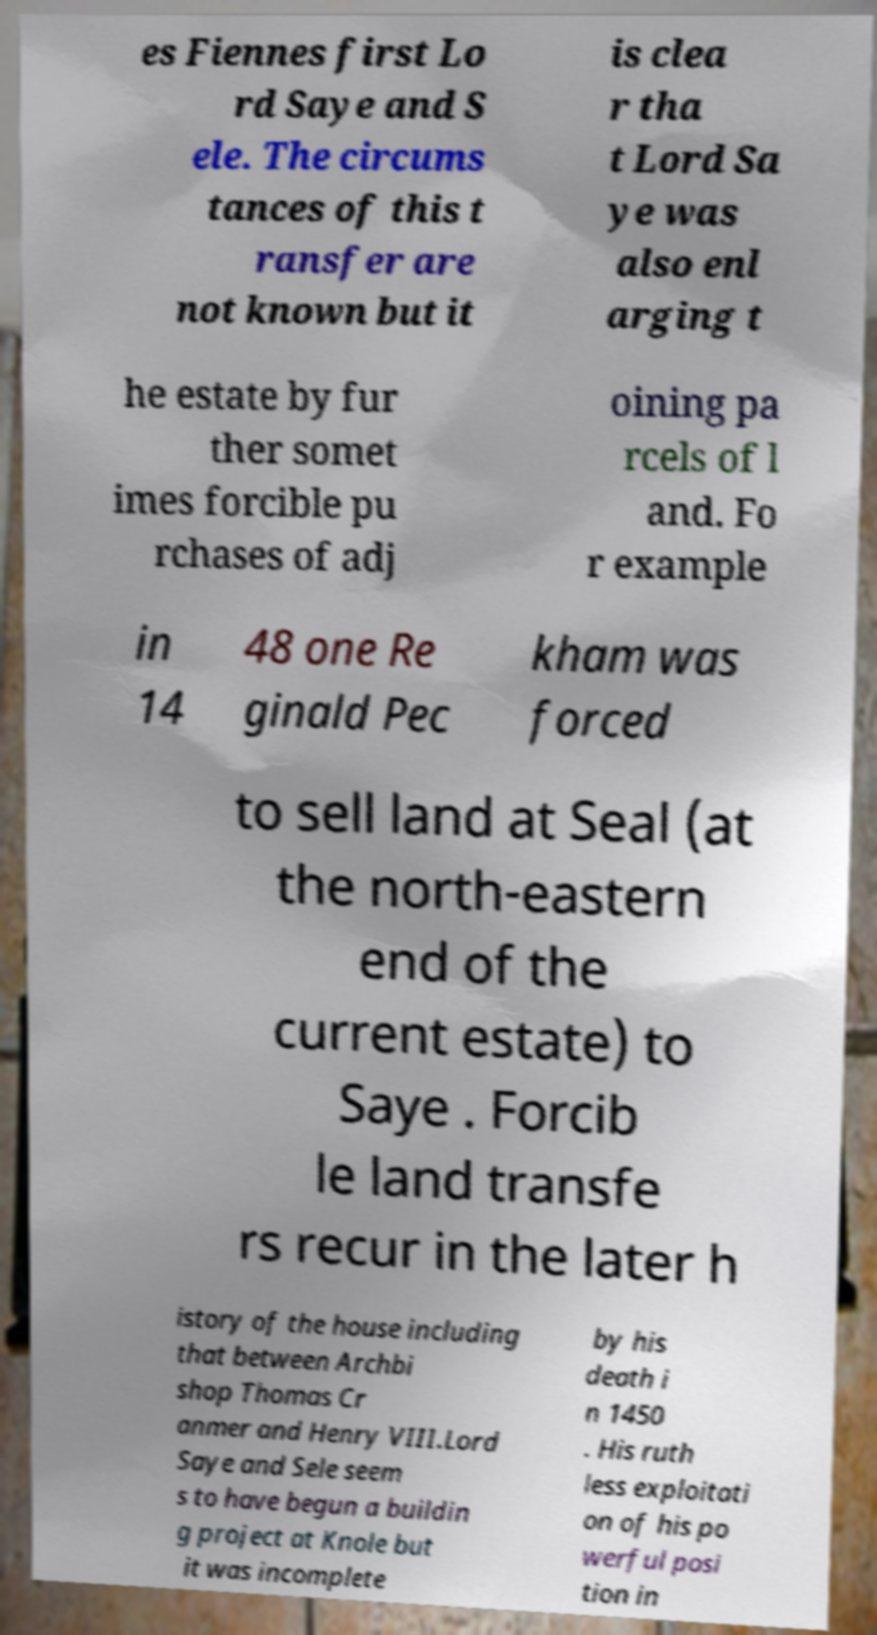There's text embedded in this image that I need extracted. Can you transcribe it verbatim? es Fiennes first Lo rd Saye and S ele. The circums tances of this t ransfer are not known but it is clea r tha t Lord Sa ye was also enl arging t he estate by fur ther somet imes forcible pu rchases of adj oining pa rcels of l and. Fo r example in 14 48 one Re ginald Pec kham was forced to sell land at Seal (at the north-eastern end of the current estate) to Saye . Forcib le land transfe rs recur in the later h istory of the house including that between Archbi shop Thomas Cr anmer and Henry VIII.Lord Saye and Sele seem s to have begun a buildin g project at Knole but it was incomplete by his death i n 1450 . His ruth less exploitati on of his po werful posi tion in 